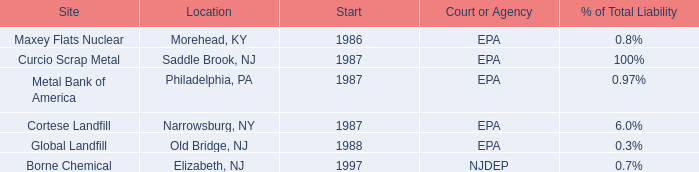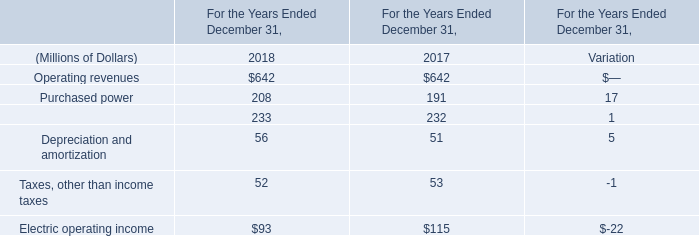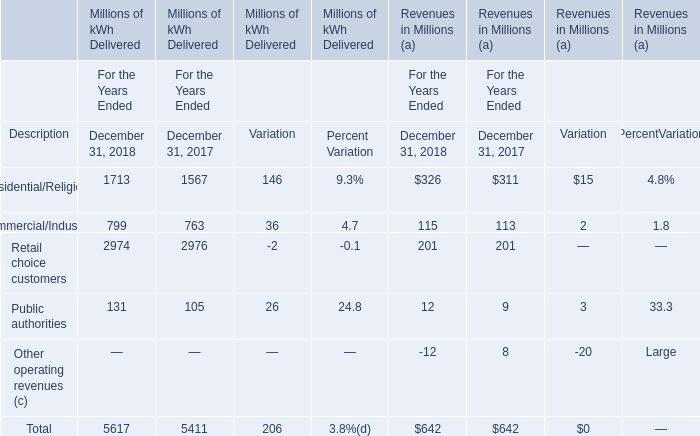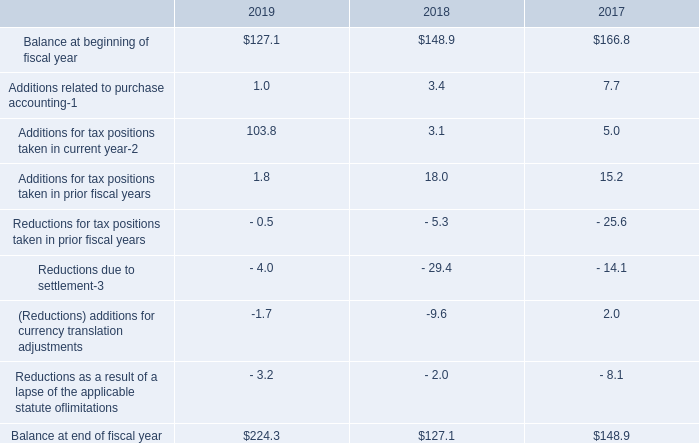by what percent did total balance increase between 2018 and 2019? 
Computations: ((224.3 - 127.1) / 127.1)
Answer: 0.76475. 